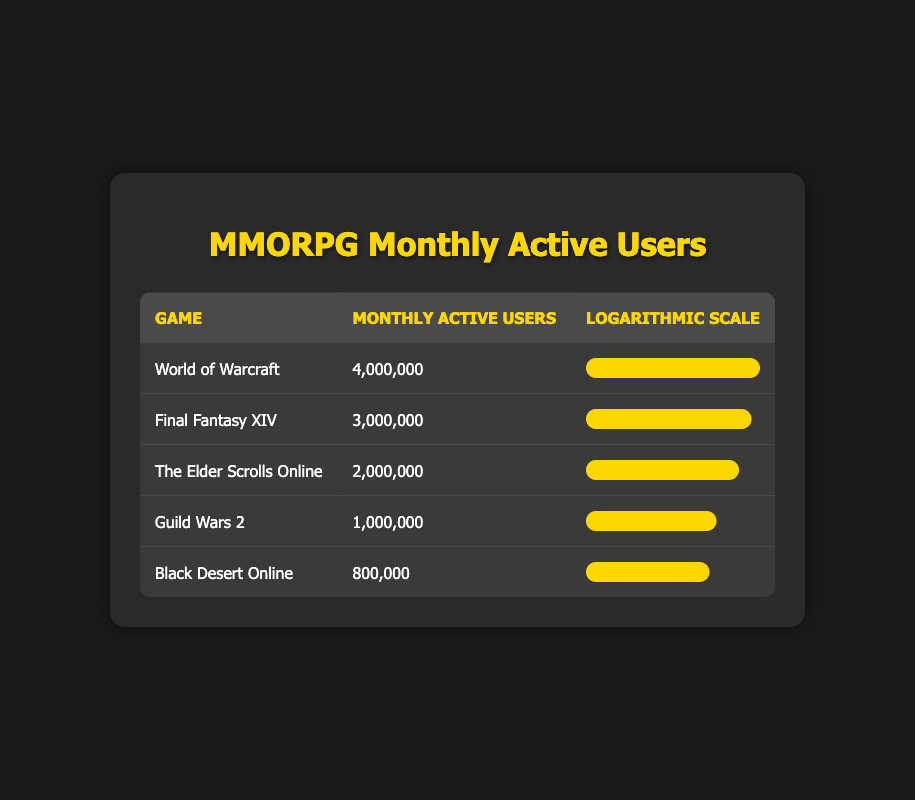What is the monthly active user count for World of Warcraft? The table shows that the monthly active user count for World of Warcraft is listed directly as 4,000,000.
Answer: 4,000,000 Which game has the highest number of monthly active users? By examining the table, World of Warcraft is highlighted as having the highest monthly active user count at 4,000,000, compared to the other games listed.
Answer: World of Warcraft What is the difference in monthly active users between Final Fantasy XIV and The Elder Scrolls Online? The monthly active users for Final Fantasy XIV is 3,000,000, and for The Elder Scrolls Online, it is 2,000,000. The difference can be calculated by subtracting 2,000,000 from 3,000,000, which equals 1,000,000.
Answer: 1,000,000 Is Black Desert Online among the top three MMORPGs by monthly active user count? The table shows that Black Desert Online has 800,000 users, which is less than the counts for World of Warcraft, Final Fantasy XIV, and The Elder Scrolls Online. Therefore, it is not in the top three.
Answer: No What is the average monthly active user count of the MMORPGs listed in the table? To find the average, add up the monthly active users: 4,000,000 + 3,000,000 + 2,000,000 + 1,000,000 + 800,000 = 10,800,000. Then divide by the number of games (5), which gives 10,800,000 / 5 = 2,160,000.
Answer: 2,160,000 Which game has the lowest number of monthly active users, and how many does it have? By visually scanning the table, it's clear that Black Desert Online has the lowest number of monthly active users at 800,000.
Answer: Black Desert Online, 800,000 If we only consider the top two MMORPGs, what percentage of the total active users do they represent? The top two games are World of Warcraft and Final Fantasy XIV with users of 4,000,000 and 3,000,000 respectively. This totals to 7,000,000. The overall total is 10,800,000. The percentage can be calculated as (7,000,000 / 10,800,000) * 100, which is approximately 64.81%.
Answer: Approximately 64.81% How many MMORPGs have monthly active users exceeding 1,500,000? By examining the table, three games (World of Warcraft, Final Fantasy XIV, and The Elder Scrolls Online) have user counts greater than 1,500,000, as only Guild Wars 2 and Black Desert Online are below that threshold.
Answer: 3 